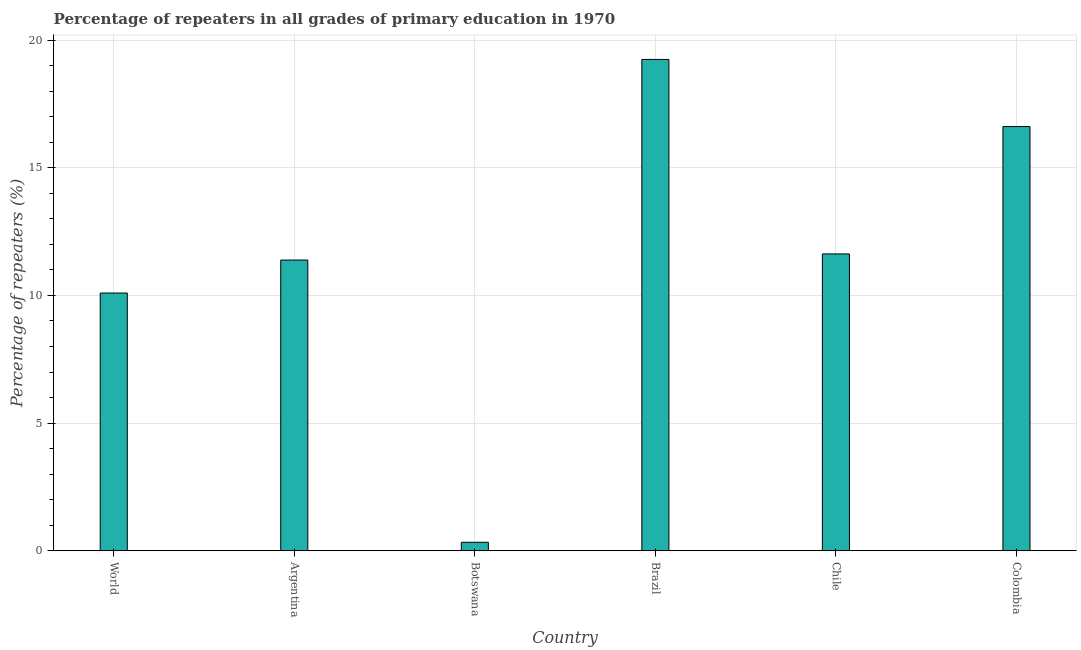What is the title of the graph?
Offer a very short reply. Percentage of repeaters in all grades of primary education in 1970. What is the label or title of the Y-axis?
Offer a terse response. Percentage of repeaters (%). What is the percentage of repeaters in primary education in Chile?
Keep it short and to the point. 11.62. Across all countries, what is the maximum percentage of repeaters in primary education?
Provide a succinct answer. 19.24. Across all countries, what is the minimum percentage of repeaters in primary education?
Your answer should be compact. 0.33. In which country was the percentage of repeaters in primary education maximum?
Keep it short and to the point. Brazil. In which country was the percentage of repeaters in primary education minimum?
Your answer should be compact. Botswana. What is the sum of the percentage of repeaters in primary education?
Provide a succinct answer. 69.29. What is the difference between the percentage of repeaters in primary education in Brazil and World?
Make the answer very short. 9.15. What is the average percentage of repeaters in primary education per country?
Your answer should be compact. 11.55. What is the median percentage of repeaters in primary education?
Your answer should be very brief. 11.5. What is the ratio of the percentage of repeaters in primary education in Argentina to that in Colombia?
Provide a short and direct response. 0.69. Is the percentage of repeaters in primary education in Argentina less than that in Colombia?
Provide a short and direct response. Yes. What is the difference between the highest and the second highest percentage of repeaters in primary education?
Provide a short and direct response. 2.63. Is the sum of the percentage of repeaters in primary education in Argentina and Botswana greater than the maximum percentage of repeaters in primary education across all countries?
Keep it short and to the point. No. What is the difference between the highest and the lowest percentage of repeaters in primary education?
Offer a terse response. 18.91. In how many countries, is the percentage of repeaters in primary education greater than the average percentage of repeaters in primary education taken over all countries?
Offer a terse response. 3. How many bars are there?
Your answer should be compact. 6. What is the difference between two consecutive major ticks on the Y-axis?
Your answer should be compact. 5. What is the Percentage of repeaters (%) in World?
Give a very brief answer. 10.09. What is the Percentage of repeaters (%) of Argentina?
Keep it short and to the point. 11.38. What is the Percentage of repeaters (%) in Botswana?
Your answer should be very brief. 0.33. What is the Percentage of repeaters (%) in Brazil?
Provide a short and direct response. 19.24. What is the Percentage of repeaters (%) in Chile?
Offer a terse response. 11.62. What is the Percentage of repeaters (%) of Colombia?
Give a very brief answer. 16.61. What is the difference between the Percentage of repeaters (%) in World and Argentina?
Give a very brief answer. -1.29. What is the difference between the Percentage of repeaters (%) in World and Botswana?
Keep it short and to the point. 9.76. What is the difference between the Percentage of repeaters (%) in World and Brazil?
Make the answer very short. -9.15. What is the difference between the Percentage of repeaters (%) in World and Chile?
Offer a very short reply. -1.53. What is the difference between the Percentage of repeaters (%) in World and Colombia?
Your answer should be compact. -6.52. What is the difference between the Percentage of repeaters (%) in Argentina and Botswana?
Ensure brevity in your answer.  11.05. What is the difference between the Percentage of repeaters (%) in Argentina and Brazil?
Provide a short and direct response. -7.86. What is the difference between the Percentage of repeaters (%) in Argentina and Chile?
Your response must be concise. -0.24. What is the difference between the Percentage of repeaters (%) in Argentina and Colombia?
Your response must be concise. -5.23. What is the difference between the Percentage of repeaters (%) in Botswana and Brazil?
Offer a terse response. -18.91. What is the difference between the Percentage of repeaters (%) in Botswana and Chile?
Keep it short and to the point. -11.29. What is the difference between the Percentage of repeaters (%) in Botswana and Colombia?
Your response must be concise. -16.28. What is the difference between the Percentage of repeaters (%) in Brazil and Chile?
Your answer should be very brief. 7.62. What is the difference between the Percentage of repeaters (%) in Brazil and Colombia?
Ensure brevity in your answer.  2.63. What is the difference between the Percentage of repeaters (%) in Chile and Colombia?
Provide a succinct answer. -4.99. What is the ratio of the Percentage of repeaters (%) in World to that in Argentina?
Provide a short and direct response. 0.89. What is the ratio of the Percentage of repeaters (%) in World to that in Botswana?
Make the answer very short. 30.35. What is the ratio of the Percentage of repeaters (%) in World to that in Brazil?
Your response must be concise. 0.53. What is the ratio of the Percentage of repeaters (%) in World to that in Chile?
Provide a short and direct response. 0.87. What is the ratio of the Percentage of repeaters (%) in World to that in Colombia?
Provide a short and direct response. 0.61. What is the ratio of the Percentage of repeaters (%) in Argentina to that in Botswana?
Provide a short and direct response. 34.24. What is the ratio of the Percentage of repeaters (%) in Argentina to that in Brazil?
Make the answer very short. 0.59. What is the ratio of the Percentage of repeaters (%) in Argentina to that in Chile?
Make the answer very short. 0.98. What is the ratio of the Percentage of repeaters (%) in Argentina to that in Colombia?
Give a very brief answer. 0.69. What is the ratio of the Percentage of repeaters (%) in Botswana to that in Brazil?
Your response must be concise. 0.02. What is the ratio of the Percentage of repeaters (%) in Botswana to that in Chile?
Your answer should be compact. 0.03. What is the ratio of the Percentage of repeaters (%) in Brazil to that in Chile?
Your answer should be compact. 1.66. What is the ratio of the Percentage of repeaters (%) in Brazil to that in Colombia?
Ensure brevity in your answer.  1.16. What is the ratio of the Percentage of repeaters (%) in Chile to that in Colombia?
Your answer should be very brief. 0.7. 